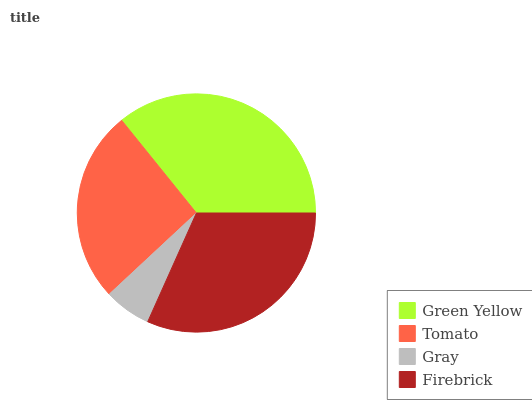Is Gray the minimum?
Answer yes or no. Yes. Is Green Yellow the maximum?
Answer yes or no. Yes. Is Tomato the minimum?
Answer yes or no. No. Is Tomato the maximum?
Answer yes or no. No. Is Green Yellow greater than Tomato?
Answer yes or no. Yes. Is Tomato less than Green Yellow?
Answer yes or no. Yes. Is Tomato greater than Green Yellow?
Answer yes or no. No. Is Green Yellow less than Tomato?
Answer yes or no. No. Is Firebrick the high median?
Answer yes or no. Yes. Is Tomato the low median?
Answer yes or no. Yes. Is Tomato the high median?
Answer yes or no. No. Is Green Yellow the low median?
Answer yes or no. No. 